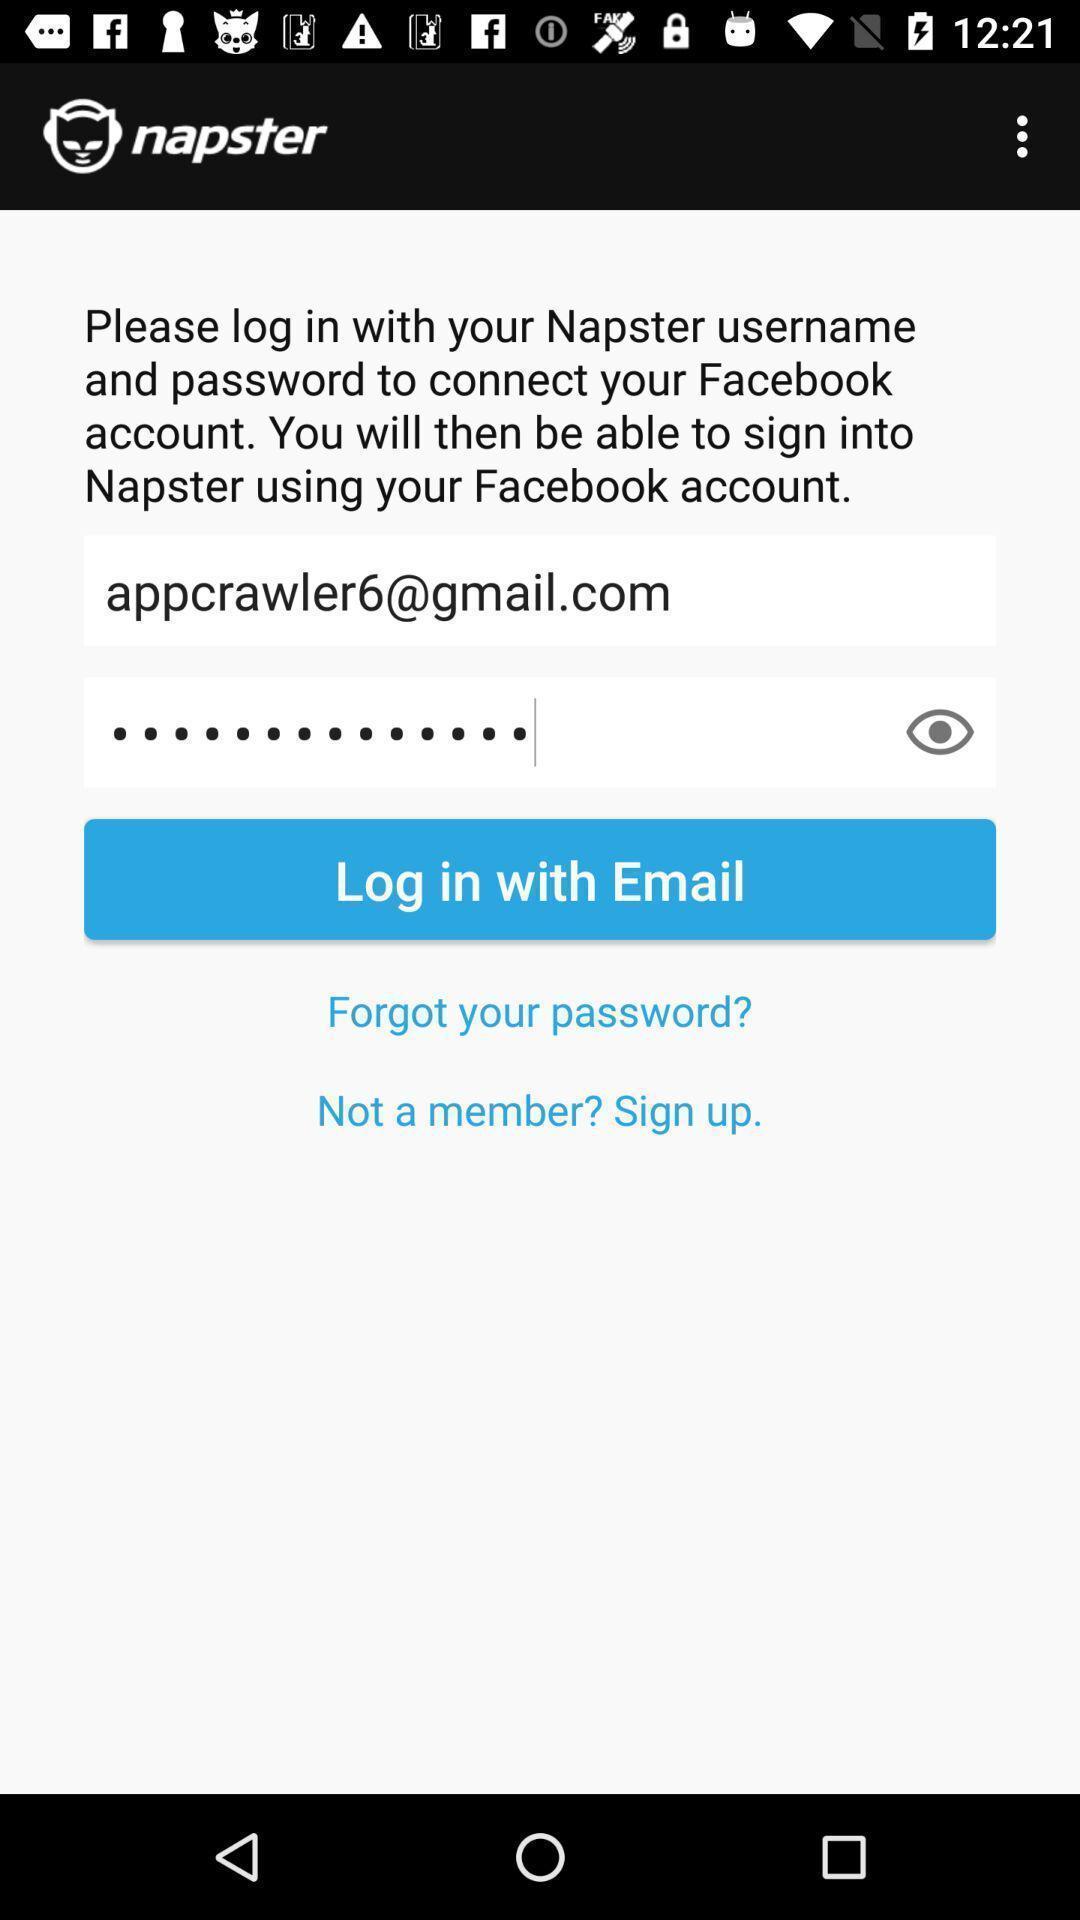Give me a summary of this screen capture. Page showing login credentials in app. 